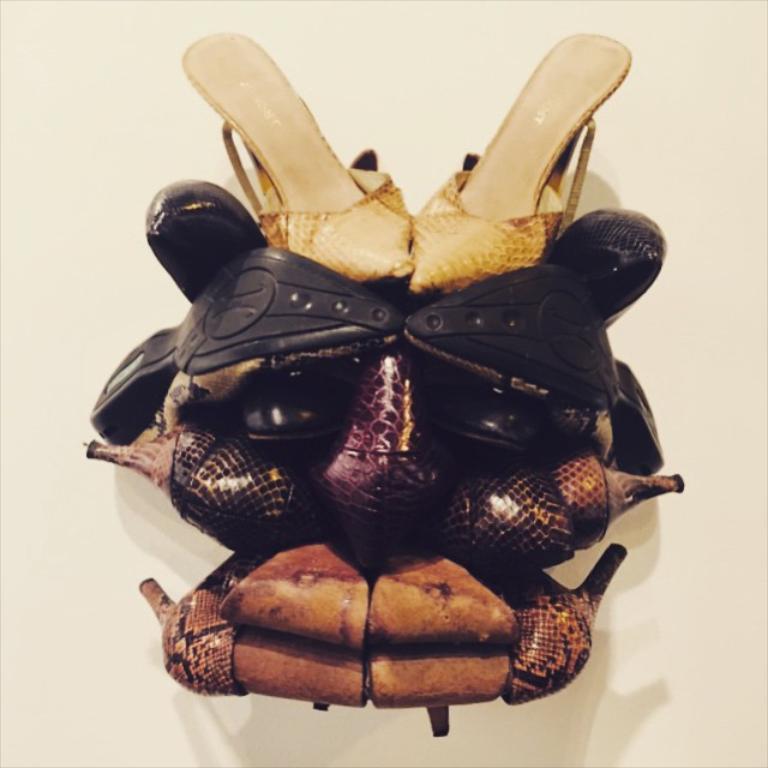Describe this image in one or two sentences. In this image there are some pairs of footwear which are arranged one above the other in some architecture manner. 